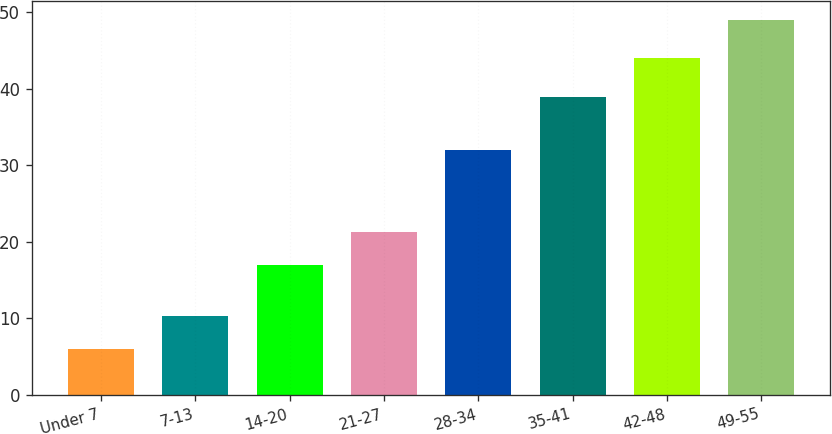<chart> <loc_0><loc_0><loc_500><loc_500><bar_chart><fcel>Under 7<fcel>7-13<fcel>14-20<fcel>21-27<fcel>28-34<fcel>35-41<fcel>42-48<fcel>49-55<nl><fcel>6<fcel>10.3<fcel>17<fcel>21.3<fcel>32<fcel>39<fcel>44<fcel>49<nl></chart> 